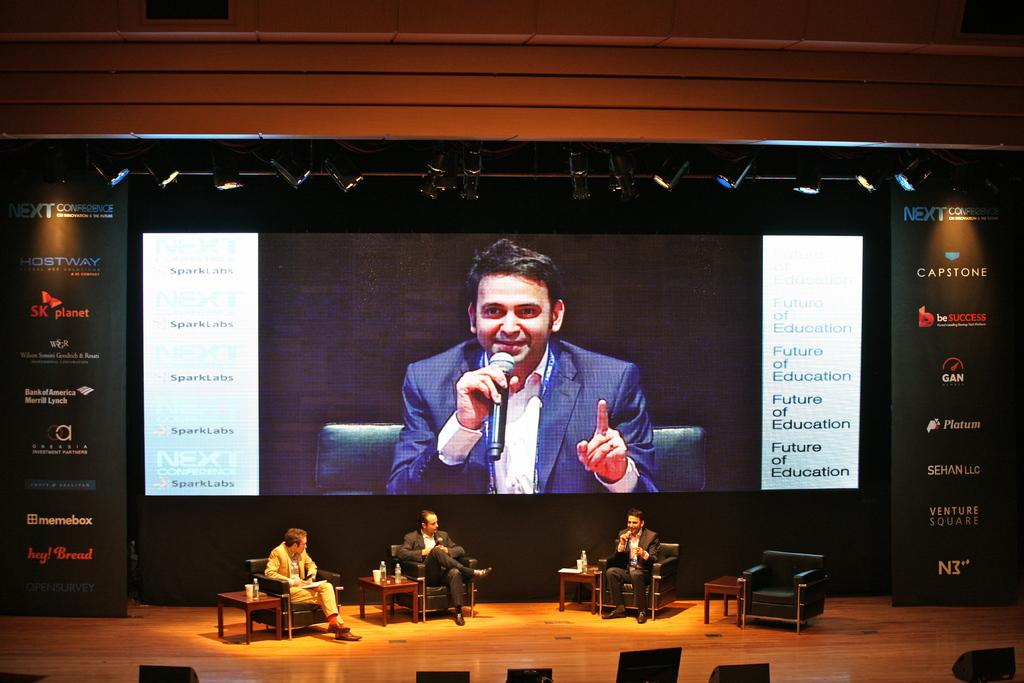<image>
Give a short and clear explanation of the subsequent image. a large projection screen behing men sitting on stage at the Next conference 